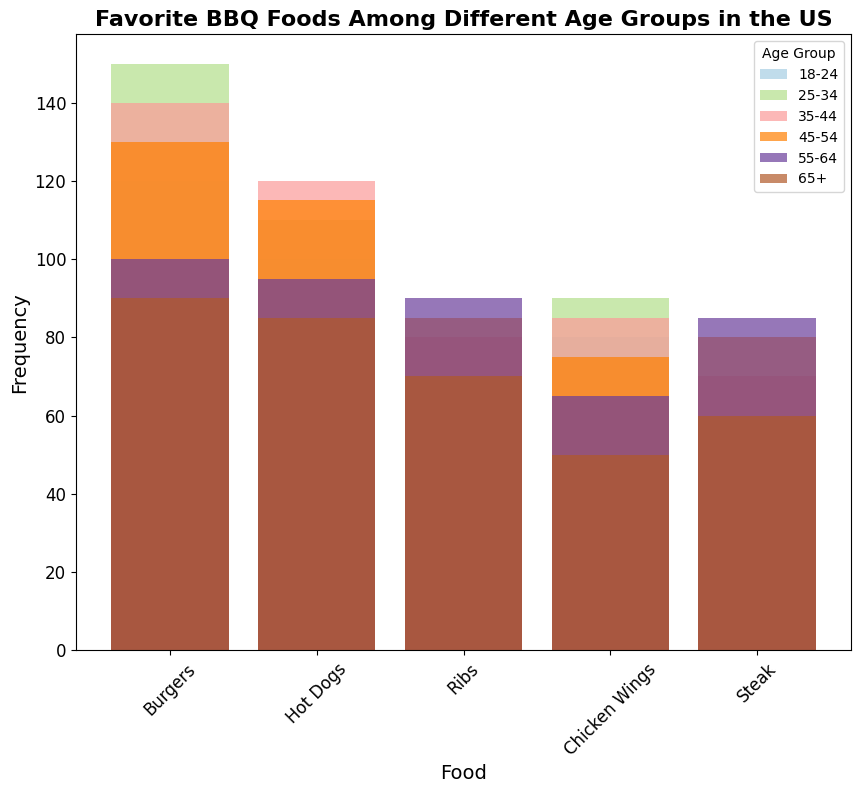Which age group has the highest preference for burgers? By looking at the visual height of the bars, the 25-34 age group has the highest bar for burgers indicating the highest frequency among all age groups.
Answer: 25-34 Which food does the age group 65+ prefer the least? The shortest bar for the 65+ age group corresponds to Chicken Wings, showing that it is the least preferred food in that age group based on the frequency.
Answer: Chicken Wings Compare the preferences for ribs between the 18-24 and 45-54 age groups. Which group prefers ribs more and by how much? The bar representing ribs for the 45-54 age group is higher than the one for the 18-24 age group. By counting the bar lengths, the 45-54 group prefers ribs by 25 more instances (85 - 60).
Answer: 45-54, by 25 Which age group has the closest frequency of preference for hot dogs and burgers? Comparing the bar heights for hot dogs and burgers across all age groups, the 65+ age group has the closest frequency, with hot dogs at 85 and burgers at 90, a difference of only 5.
Answer: 65+ Are chicken wings more preferred by the 25-34 age group or the 35-44 age group? By comparing the height of the bars for chicken wings in these two age groups, the 25-34 age group has a taller bar for chicken wings (90) compared to the 35-44 age group (85).
Answer: 25-34 Which age group shows the highest preference for steak and what is its frequency? The tallest bar for steak is seen in the 55-64 age group, indicating the highest preference. The frequency is 85.
Answer: 55-64, 85 What is the total frequency of hot dog preferences across all age groups? Sum the frequencies of hot dog preferences across all age groups: 100 + 110 + 120 + 115 + 95 + 85 = 625.
Answer: 625 How do the preferences for steak among the 35-44 and 55-64 age groups compare? The bar for steak in the 55-64 age group is higher than that of the 35-44 age group. By counting the difference, 55-64 has 85, while 35-44 has 70, making a difference of 15.
Answer: 55-64, by 15 Which food category has the widest range of preferences across all age groups? By comparing the range, or difference between the highest and lowest frequencies for each food category across all age groups, we see that burgers have the widest range (from 90 to 150), a range of 60.
Answer: Burgers Is there any food that is consistently less preferred by older age groups (55-64, 65+) compared to younger age groups (18-24, 25-34)? If yes, identify the food. Chicken Wings appears consistently less preferred by older age groups compared to younger ones. The bars for Chicken Wings are shorter in the 55-64 and 65+ groups compared to the 18-24 and 25-34 groups.
Answer: Chicken Wings 